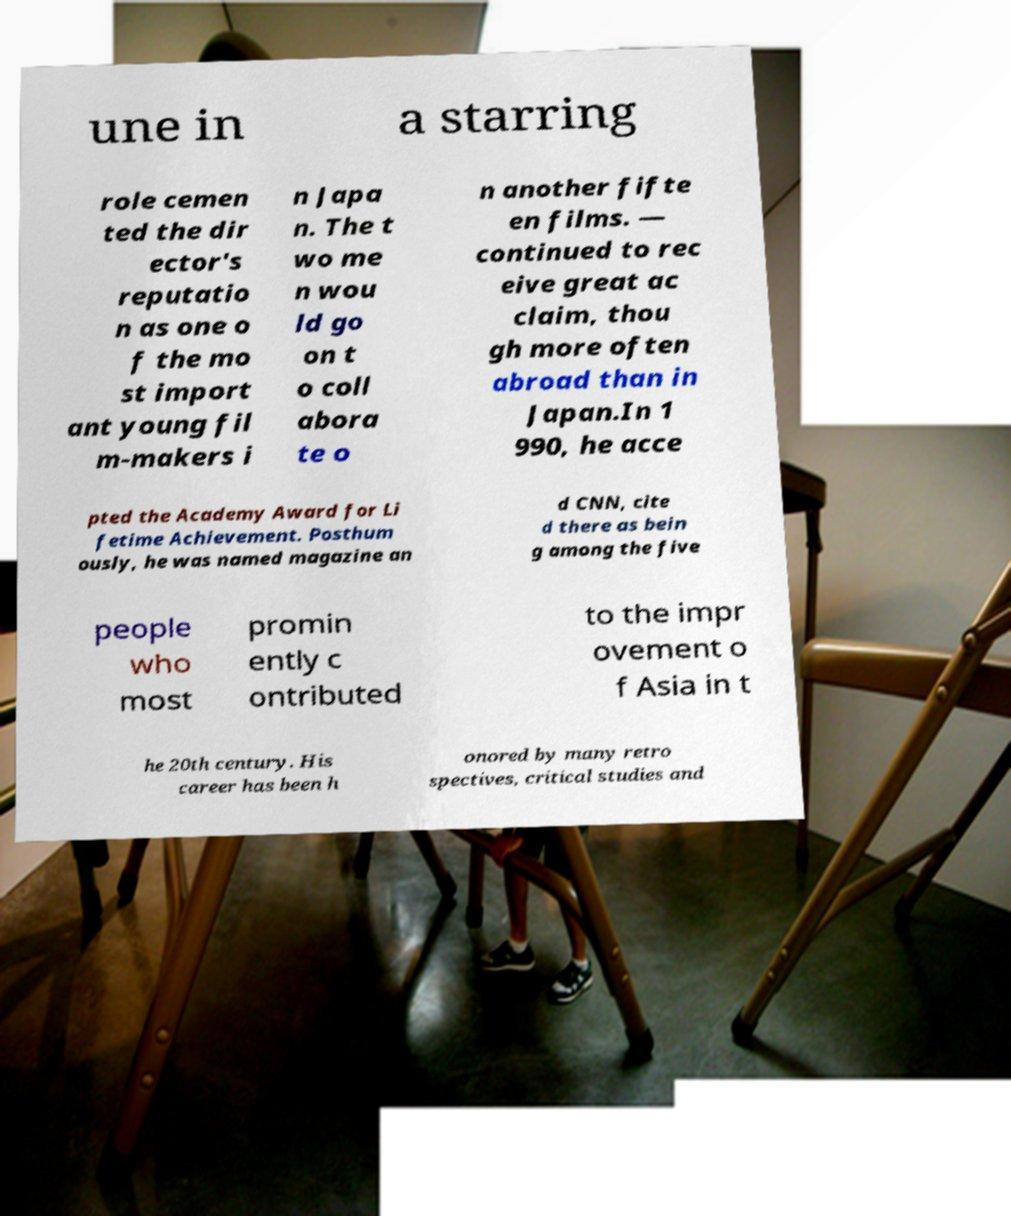Please read and relay the text visible in this image. What does it say? une in a starring role cemen ted the dir ector's reputatio n as one o f the mo st import ant young fil m-makers i n Japa n. The t wo me n wou ld go on t o coll abora te o n another fifte en films. — continued to rec eive great ac claim, thou gh more often abroad than in Japan.In 1 990, he acce pted the Academy Award for Li fetime Achievement. Posthum ously, he was named magazine an d CNN, cite d there as bein g among the five people who most promin ently c ontributed to the impr ovement o f Asia in t he 20th century. His career has been h onored by many retro spectives, critical studies and 